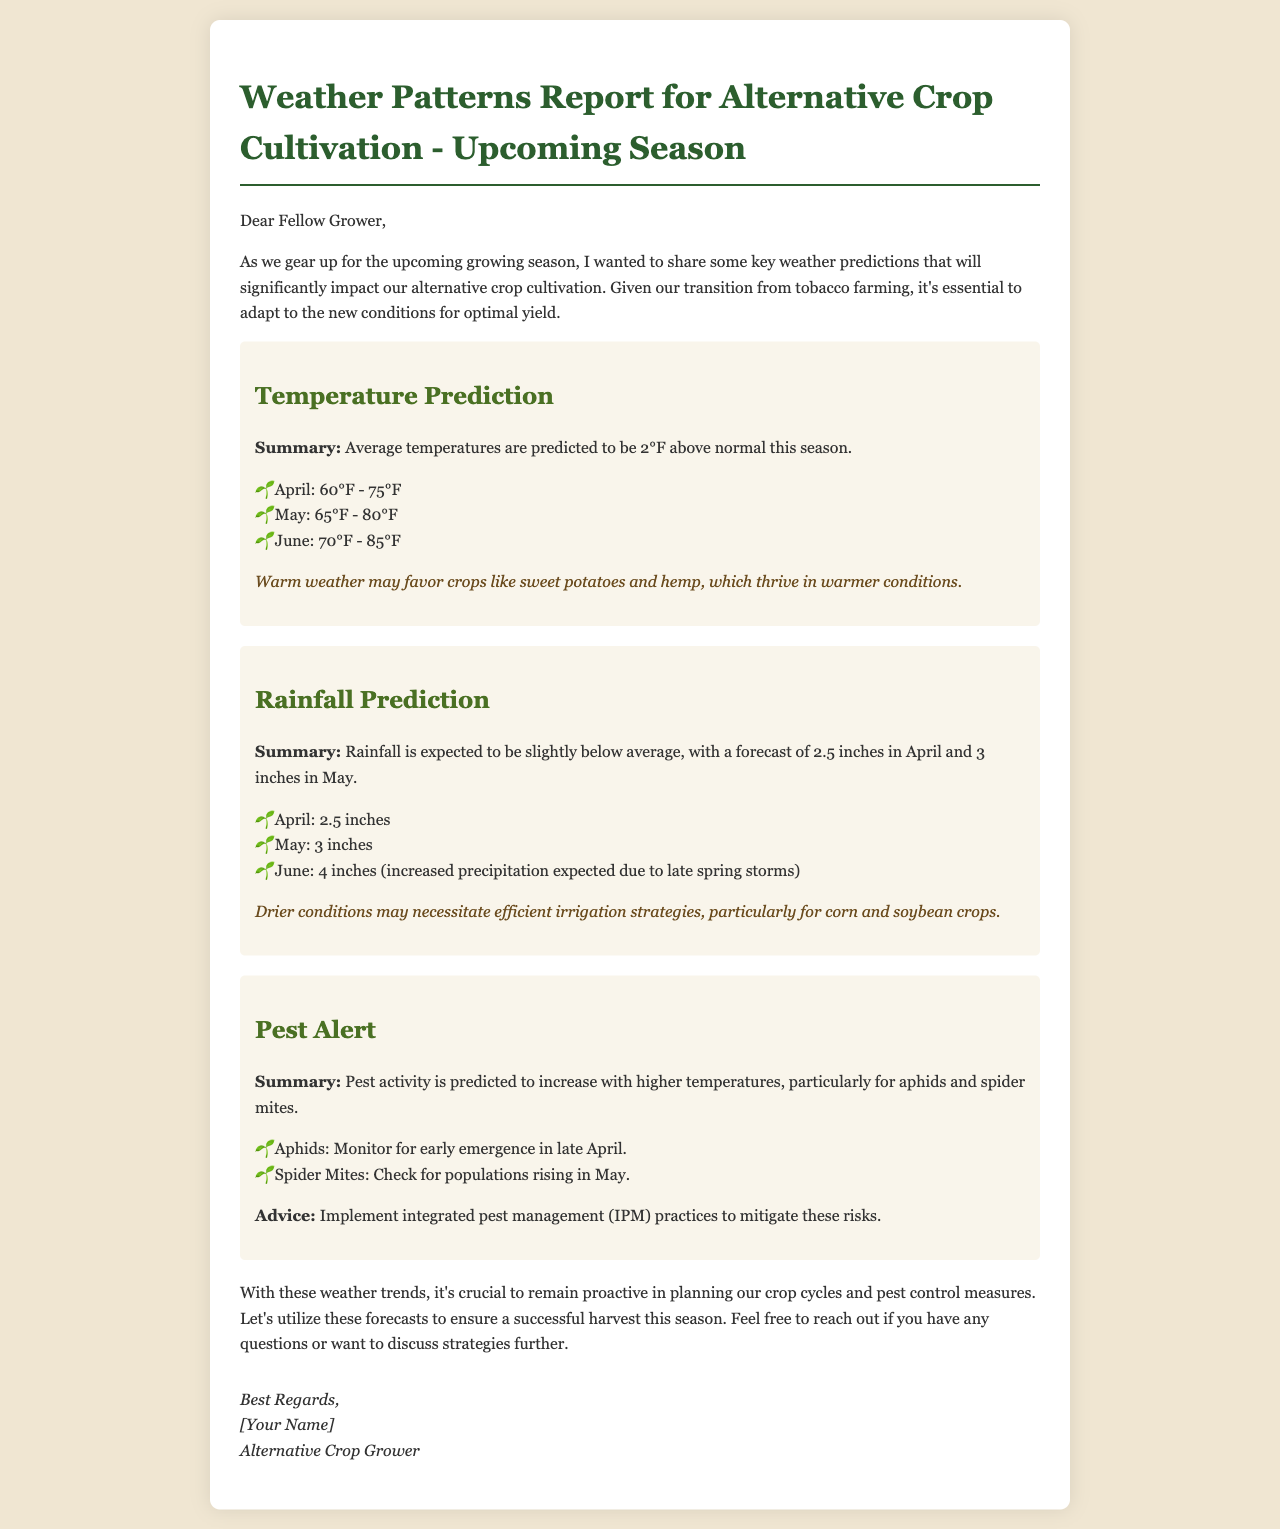What is the predicted average temperature increase this season? The document states that average temperatures are predicted to be 2°F above normal this season.
Answer: 2°F How much rainfall is forecasted for May? The document lists the expected rainfall for May as 3 inches.
Answer: 3 inches What crops may thrive in warmer weather? The document indicates that warm weather may favor crops like sweet potatoes and hemp.
Answer: sweet potatoes and hemp When should growers monitor for aphids? The document advises to monitor for early emergence of aphids in late April.
Answer: late April What integrated management strategy is recommended? The document recommends implementing integrated pest management (IPM) practices to mitigate pest risks.
Answer: integrated pest management (IPM) What is the rainfall prediction for June? According to the document, June is expected to have 4 inches of rainfall due to late spring storms.
Answer: 4 inches Which pests are highlighted for monitoring due to temperature increases? The document mentions that pest activity, specifically for aphids and spider mites, is predicted to increase.
Answer: aphids and spider mites What is the advice for drier conditions impacting irrigation? The document explains that drier conditions may necessitate efficient irrigation strategies.
Answer: efficient irrigation strategies What does the document suggest for crop planning? The document emphasizes the importance of remaining proactive in planning crop cycles and pest control measures.
Answer: proactive planning 